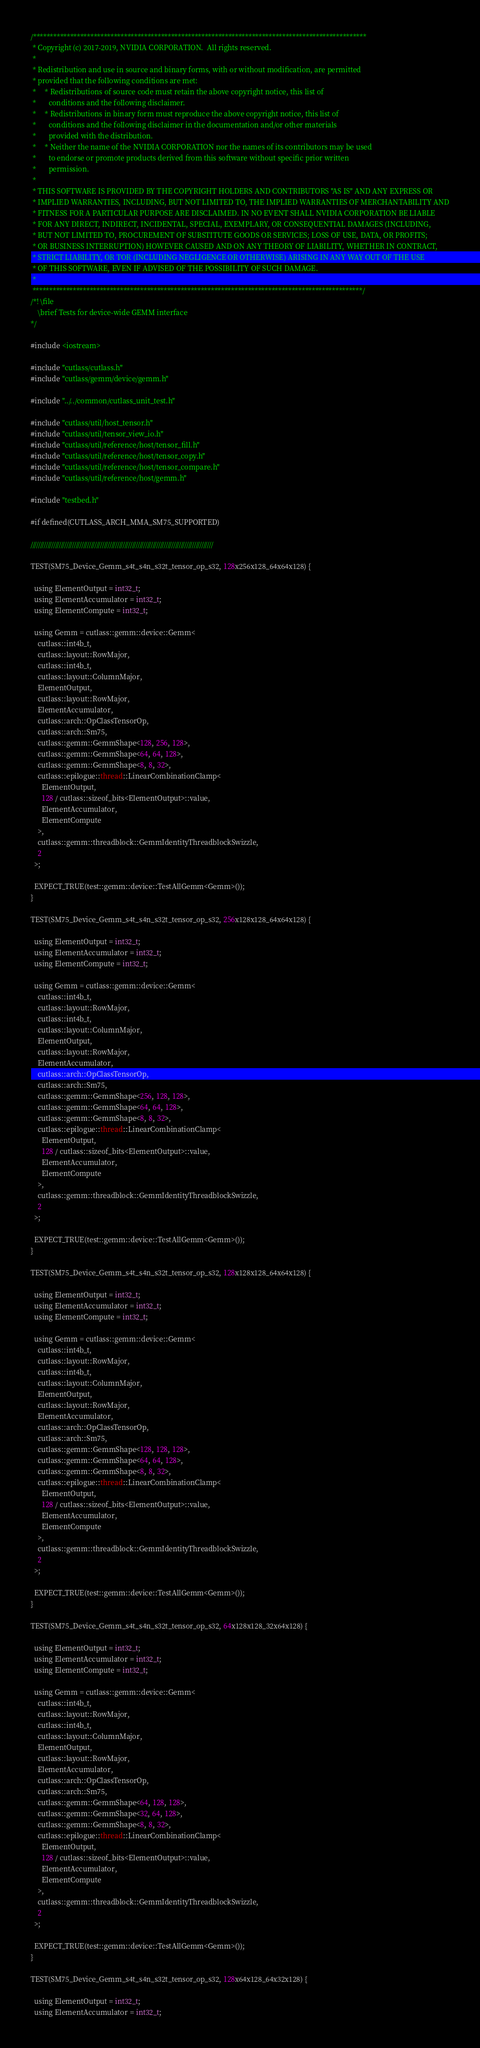<code> <loc_0><loc_0><loc_500><loc_500><_Cuda_>/***************************************************************************************************
 * Copyright (c) 2017-2019, NVIDIA CORPORATION.  All rights reserved.
 *
 * Redistribution and use in source and binary forms, with or without modification, are permitted
 * provided that the following conditions are met:
 *     * Redistributions of source code must retain the above copyright notice, this list of
 *       conditions and the following disclaimer.
 *     * Redistributions in binary form must reproduce the above copyright notice, this list of
 *       conditions and the following disclaimer in the documentation and/or other materials
 *       provided with the distribution.
 *     * Neither the name of the NVIDIA CORPORATION nor the names of its contributors may be used
 *       to endorse or promote products derived from this software without specific prior written
 *       permission.
 *
 * THIS SOFTWARE IS PROVIDED BY THE COPYRIGHT HOLDERS AND CONTRIBUTORS "AS IS" AND ANY EXPRESS OR
 * IMPLIED WARRANTIES, INCLUDING, BUT NOT LIMITED TO, THE IMPLIED WARRANTIES OF MERCHANTABILITY AND
 * FITNESS FOR A PARTICULAR PURPOSE ARE DISCLAIMED. IN NO EVENT SHALL NVIDIA CORPORATION BE LIABLE
 * FOR ANY DIRECT, INDIRECT, INCIDENTAL, SPECIAL, EXEMPLARY, OR CONSEQUENTIAL DAMAGES (INCLUDING,
 * BUT NOT LIMITED TO, PROCUREMENT OF SUBSTITUTE GOODS OR SERVICES; LOSS OF USE, DATA, OR PROFITS;
 * OR BUSINESS INTERRUPTION) HOWEVER CAUSED AND ON ANY THEORY OF LIABILITY, WHETHER IN CONTRACT,
 * STRICT LIABILITY, OR TOR (INCLUDING NEGLIGENCE OR OTHERWISE) ARISING IN ANY WAY OUT OF THE USE
 * OF THIS SOFTWARE, EVEN IF ADVISED OF THE POSSIBILITY OF SUCH DAMAGE.
 *
 **************************************************************************************************/
/*! \file
    \brief Tests for device-wide GEMM interface
*/

#include <iostream>

#include "cutlass/cutlass.h"
#include "cutlass/gemm/device/gemm.h"

#include "../../common/cutlass_unit_test.h"

#include "cutlass/util/host_tensor.h"
#include "cutlass/util/tensor_view_io.h"
#include "cutlass/util/reference/host/tensor_fill.h"
#include "cutlass/util/reference/host/tensor_copy.h"
#include "cutlass/util/reference/host/tensor_compare.h"
#include "cutlass/util/reference/host/gemm.h"

#include "testbed.h"

#if defined(CUTLASS_ARCH_MMA_SM75_SUPPORTED)

/////////////////////////////////////////////////////////////////////////////////////////////////

TEST(SM75_Device_Gemm_s4t_s4n_s32t_tensor_op_s32, 128x256x128_64x64x128) {

  using ElementOutput = int32_t;
  using ElementAccumulator = int32_t;
  using ElementCompute = int32_t;

  using Gemm = cutlass::gemm::device::Gemm<
    cutlass::int4b_t,
    cutlass::layout::RowMajor,
    cutlass::int4b_t,
    cutlass::layout::ColumnMajor,
    ElementOutput,
    cutlass::layout::RowMajor,
    ElementAccumulator,
    cutlass::arch::OpClassTensorOp,
    cutlass::arch::Sm75,
    cutlass::gemm::GemmShape<128, 256, 128>,
    cutlass::gemm::GemmShape<64, 64, 128>,
    cutlass::gemm::GemmShape<8, 8, 32>,
    cutlass::epilogue::thread::LinearCombinationClamp<
      ElementOutput,
      128 / cutlass::sizeof_bits<ElementOutput>::value,
      ElementAccumulator,
      ElementCompute
    >,
    cutlass::gemm::threadblock::GemmIdentityThreadblockSwizzle,
    2
  >;

  EXPECT_TRUE(test::gemm::device::TestAllGemm<Gemm>());
}

TEST(SM75_Device_Gemm_s4t_s4n_s32t_tensor_op_s32, 256x128x128_64x64x128) {

  using ElementOutput = int32_t;
  using ElementAccumulator = int32_t;
  using ElementCompute = int32_t;

  using Gemm = cutlass::gemm::device::Gemm<
    cutlass::int4b_t,
    cutlass::layout::RowMajor,
    cutlass::int4b_t,
    cutlass::layout::ColumnMajor,
    ElementOutput,
    cutlass::layout::RowMajor,
    ElementAccumulator,
    cutlass::arch::OpClassTensorOp,
    cutlass::arch::Sm75,
    cutlass::gemm::GemmShape<256, 128, 128>,
    cutlass::gemm::GemmShape<64, 64, 128>,
    cutlass::gemm::GemmShape<8, 8, 32>,
    cutlass::epilogue::thread::LinearCombinationClamp<
      ElementOutput,
      128 / cutlass::sizeof_bits<ElementOutput>::value,
      ElementAccumulator,
      ElementCompute
    >,
    cutlass::gemm::threadblock::GemmIdentityThreadblockSwizzle,
    2
  >;

  EXPECT_TRUE(test::gemm::device::TestAllGemm<Gemm>());
}

TEST(SM75_Device_Gemm_s4t_s4n_s32t_tensor_op_s32, 128x128x128_64x64x128) {

  using ElementOutput = int32_t;
  using ElementAccumulator = int32_t;
  using ElementCompute = int32_t;

  using Gemm = cutlass::gemm::device::Gemm<
    cutlass::int4b_t,
    cutlass::layout::RowMajor,
    cutlass::int4b_t,
    cutlass::layout::ColumnMajor,
    ElementOutput,
    cutlass::layout::RowMajor,
    ElementAccumulator,
    cutlass::arch::OpClassTensorOp,
    cutlass::arch::Sm75,
    cutlass::gemm::GemmShape<128, 128, 128>,
    cutlass::gemm::GemmShape<64, 64, 128>,
    cutlass::gemm::GemmShape<8, 8, 32>,
    cutlass::epilogue::thread::LinearCombinationClamp<
      ElementOutput,
      128 / cutlass::sizeof_bits<ElementOutput>::value,
      ElementAccumulator,
      ElementCompute
    >,
    cutlass::gemm::threadblock::GemmIdentityThreadblockSwizzle,
    2
  >;

  EXPECT_TRUE(test::gemm::device::TestAllGemm<Gemm>());
}

TEST(SM75_Device_Gemm_s4t_s4n_s32t_tensor_op_s32, 64x128x128_32x64x128) {

  using ElementOutput = int32_t;
  using ElementAccumulator = int32_t;
  using ElementCompute = int32_t;

  using Gemm = cutlass::gemm::device::Gemm<
    cutlass::int4b_t,
    cutlass::layout::RowMajor,
    cutlass::int4b_t,
    cutlass::layout::ColumnMajor,
    ElementOutput,
    cutlass::layout::RowMajor,
    ElementAccumulator,
    cutlass::arch::OpClassTensorOp,
    cutlass::arch::Sm75,
    cutlass::gemm::GemmShape<64, 128, 128>,
    cutlass::gemm::GemmShape<32, 64, 128>,
    cutlass::gemm::GemmShape<8, 8, 32>,
    cutlass::epilogue::thread::LinearCombinationClamp<
      ElementOutput,
      128 / cutlass::sizeof_bits<ElementOutput>::value,
      ElementAccumulator,
      ElementCompute
    >,
    cutlass::gemm::threadblock::GemmIdentityThreadblockSwizzle,
    2
  >;

  EXPECT_TRUE(test::gemm::device::TestAllGemm<Gemm>());
}

TEST(SM75_Device_Gemm_s4t_s4n_s32t_tensor_op_s32, 128x64x128_64x32x128) {

  using ElementOutput = int32_t;
  using ElementAccumulator = int32_t;</code> 